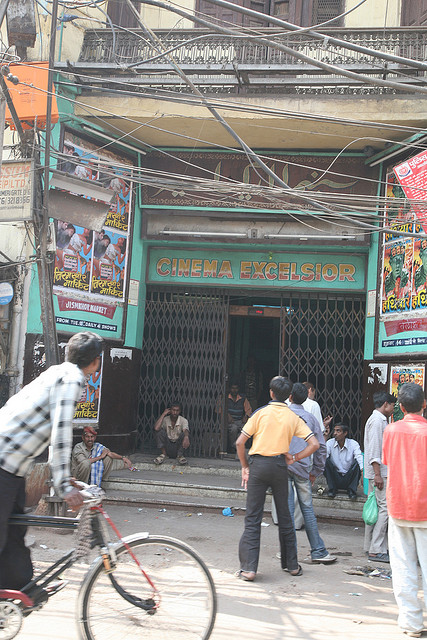What are the main objects you can see in the image? The image captures a bustling street scene. The most notable elements include the prominently displayed entrance of 'CINEMA EXCELSIOR', an array of tangled electrical wires above, several people interacting near the entrance, and a person riding a bicycle. The cinema walls are adorned with colorful posters, suggesting it plays a central role in the community’s social life. Overall, it portrays a typical day in an energetic urban setting. 